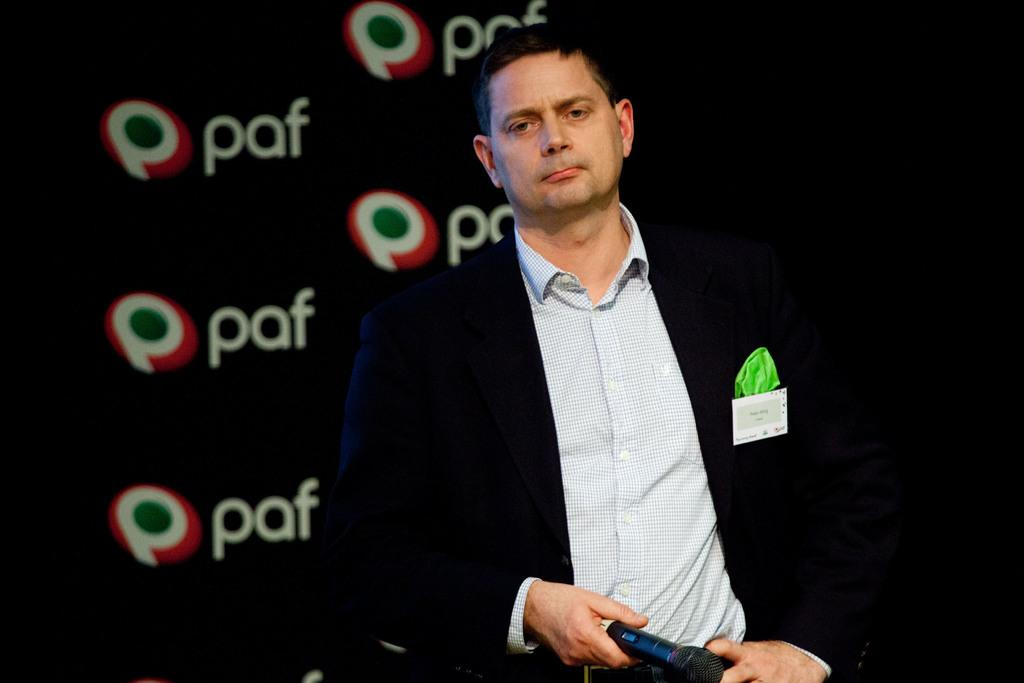Who is in the image? There is a man in the image. What is the man doing in the image? The man is standing in the image. What is the man holding in the image? The man is holding a microphone (mike) in the image. What can be seen in the background of the image? There is a black banner in the image with the text "paf" written on it. What type of fruit is being weighed on the scale in the image? There is no scale or fruit present in the image. Who is the expert giving a lecture about the fruit in the image? There is no expert or lecture about fruit in the image. 